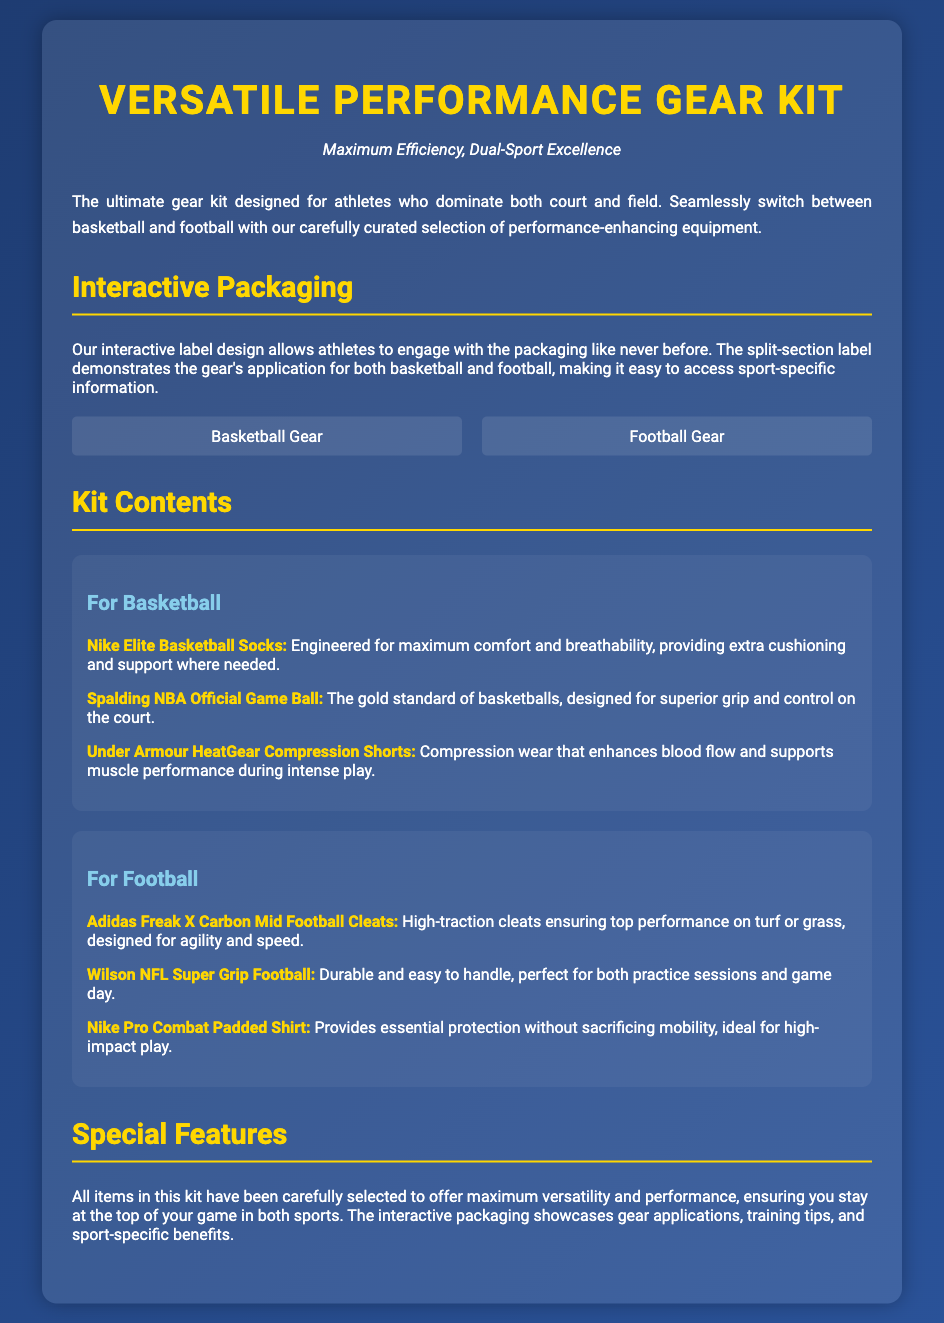What is the title of the product? The title of the product is prominently displayed at the top of the document.
Answer: Versatile Performance Gear Kit What sport gear does the package enhance? The document mentions the sports directly in the title and throughout the description.
Answer: Basketball and Football What is the first item listed for basketball? The first item is presented in a bullet point under the basketball subsection.
Answer: Nike Elite Basketball Socks What type of packaging does the product have? The document describes the packaging as interactive, allowing engagement with sport-specific information.
Answer: Interactive Packaging How many items are listed for football? The number of items can be counted directly from the football section of the document.
Answer: Three What brand is associated with the official game ball for basketball? The document lists the specific brand next to the basketball item description.
Answer: Spalding Which item provides protection and mobility for football? The document specifies an item's function in the football subsection.
Answer: Nike Pro Combat Padded Shirt What color is used in the title? The title's color is explicitly mentioned in the styling part of the document.
Answer: Gold What is the subtitle of the product? The subtitle is mentioned just below the product title in the document.
Answer: Maximum Efficiency, Dual-Sport Excellence 